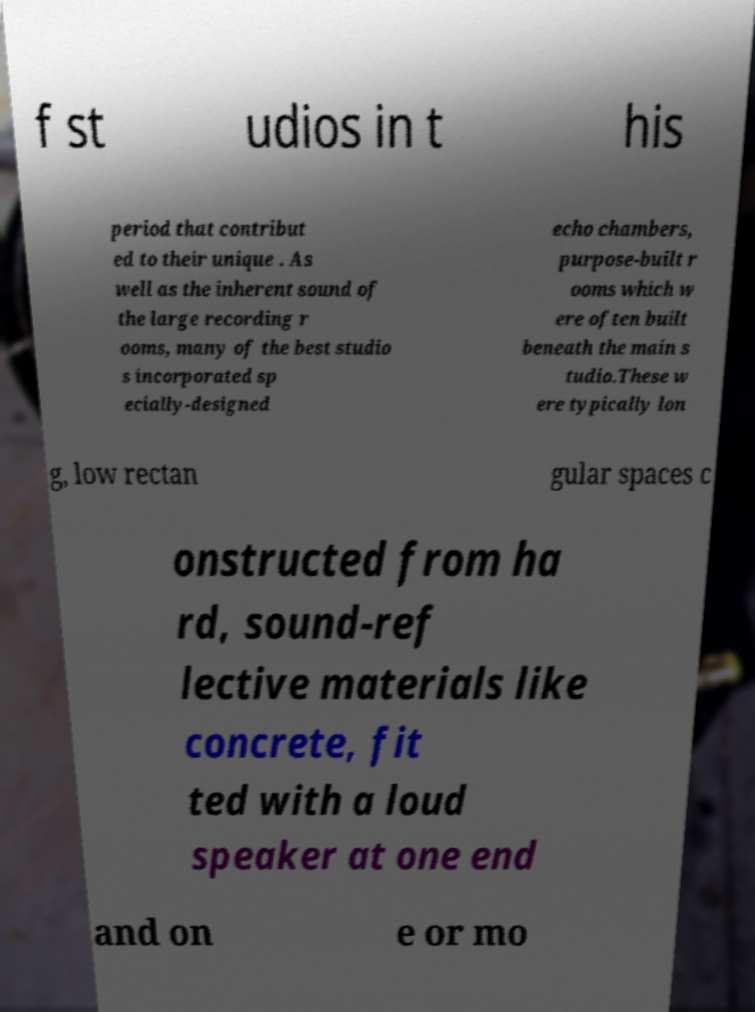For documentation purposes, I need the text within this image transcribed. Could you provide that? f st udios in t his period that contribut ed to their unique . As well as the inherent sound of the large recording r ooms, many of the best studio s incorporated sp ecially-designed echo chambers, purpose-built r ooms which w ere often built beneath the main s tudio.These w ere typically lon g, low rectan gular spaces c onstructed from ha rd, sound-ref lective materials like concrete, fit ted with a loud speaker at one end and on e or mo 